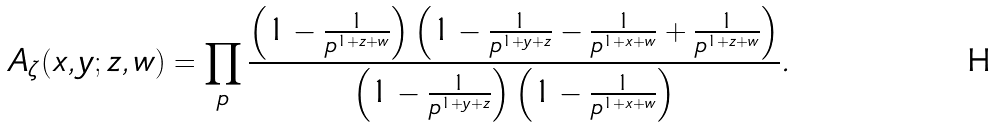Convert formula to latex. <formula><loc_0><loc_0><loc_500><loc_500>A _ { \zeta } ( x , y ; z , w ) = \prod _ { p } \frac { \left ( 1 - \frac { 1 } { p ^ { 1 + z + w } } \right ) \left ( 1 - \frac { 1 } { p ^ { 1 + y + z } } - \frac { 1 } { p ^ { 1 + x + w } } + \frac { 1 } { p ^ { 1 + z + w } } \right ) } { \left ( 1 - \frac { 1 } { p ^ { 1 + y + z } } \right ) \left ( 1 - \frac { 1 } { p ^ { 1 + x + w } } \right ) } .</formula> 